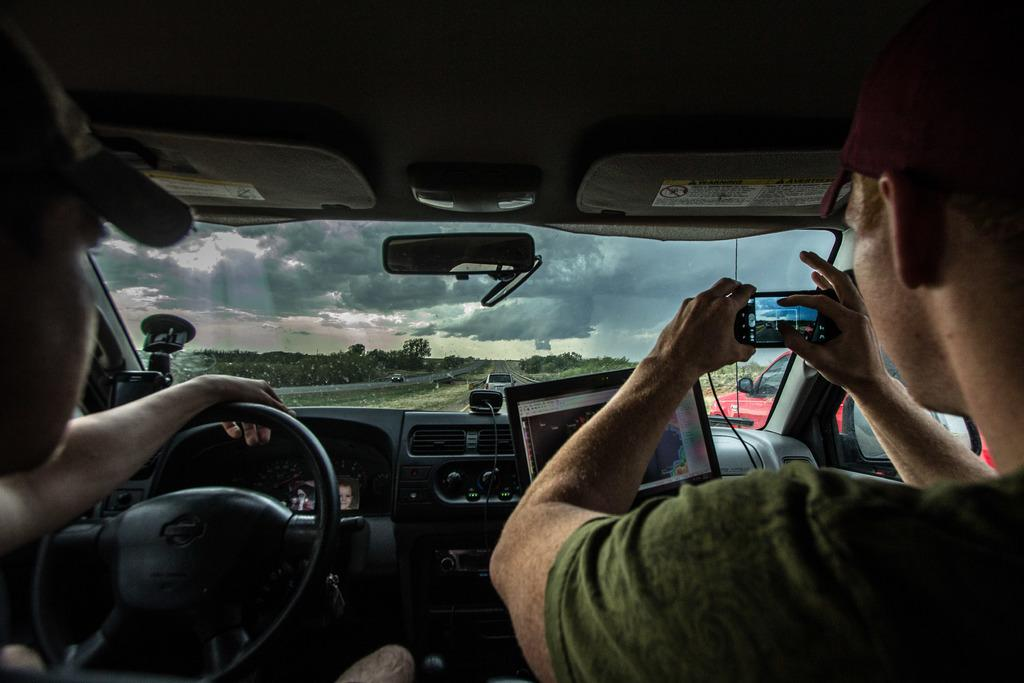What is happening in the image involving people? There are people in a vehicle in the image. What can be seen through the vehicle's glass? Grass, other vehicles, plants, trees, and the sky with clouds are visible through the vehicle's glass. Can you describe the natural environment visible through the vehicle's glass? The natural environment includes grass, plants, and trees. What is the condition of the sky visible through the vehicle's glass? The sky is visible through the vehicle's glass, with clouds present. Can you see a friend waving at the vehicle from the lake in the image? There is no lake or friend visible in the image; the focus is on the people in the vehicle and their view through the glass. 